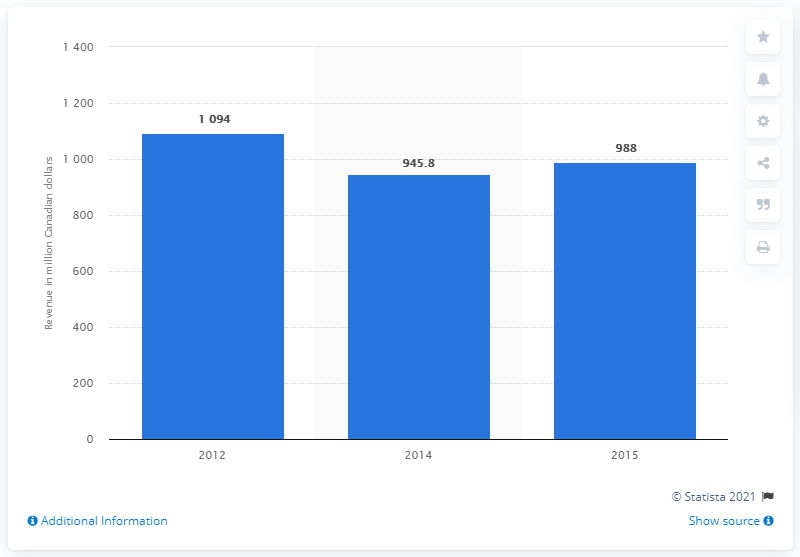List a handful of essential elements in this visual. The box office revenue in Canada was $945.8 million a year earlier. The box office revenue in Canada in the last measured period was $988. 